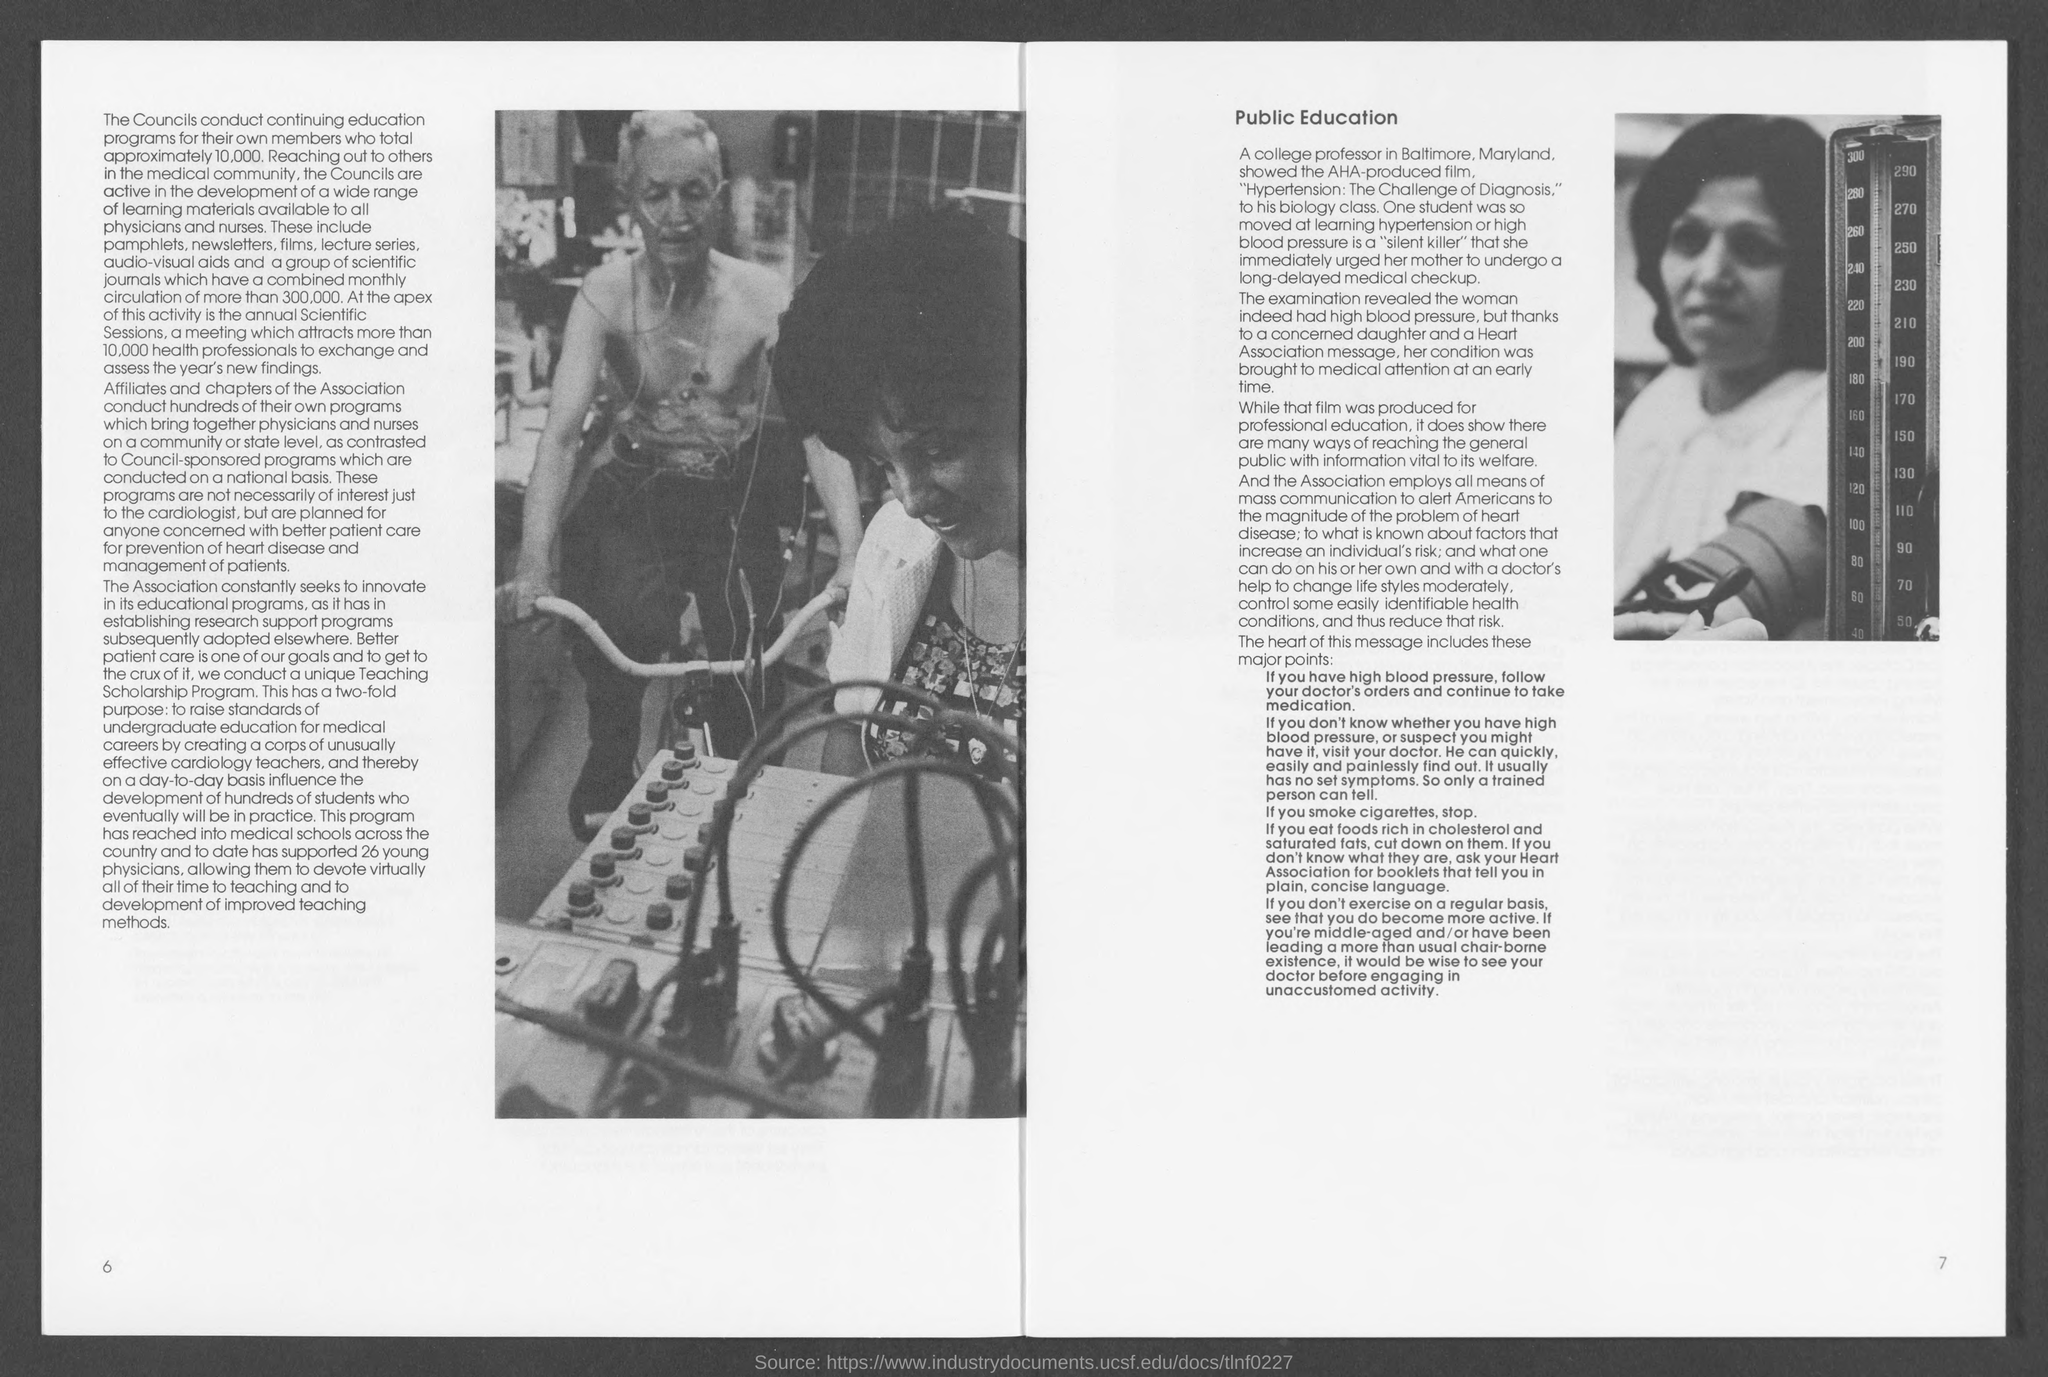List a handful of essential elements in this visual. The number at the bottom-right corner of the page is 7. The number in the bottom-left corner of the page is 6. 